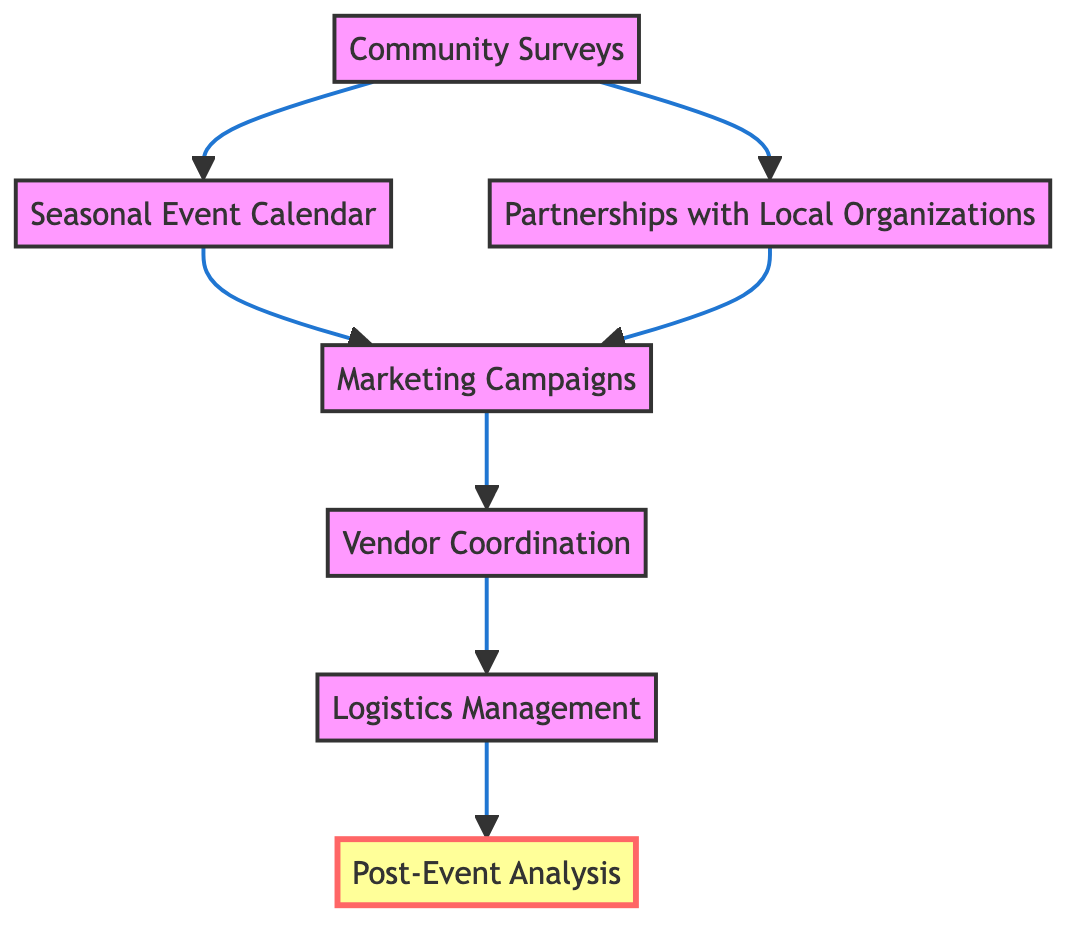What is the first step in the flow chart? The diagram indicates that "Community Surveys" is the first step, as it is the starting point and connects to further actions.
Answer: Community Surveys How many nodes are in the diagram? The diagram shows a total of 7 distinct nodes: Community Surveys, Seasonal Event Calendar, Partnerships with Local Organizations, Marketing Campaigns, Vendor Coordination, Logistics Management, and Post-Event Analysis.
Answer: 7 What connects "Community Surveys" to "Marketing Campaigns"? "Community Surveys" connects to "Marketing Campaigns" through two paths: one leading through "Seasonal Event Calendar" and the other through "Partnerships with Local Organizations."
Answer: Two paths Which node is associated with evaluating events? The last node, "Post-Event Analysis," focuses on evaluating attendance and feedback to enhance future events, thus is associated with evaluation.
Answer: Post-Event Analysis What is the last action in the flow? The last action in the flow is "Post-Event Analysis," which comes after all planning and execution steps have been completed.
Answer: Post-Event Analysis How many connections lead to "Vendor Coordination"? There are two connections leading to "Vendor Coordination": one from "Marketing Campaigns" and one from "Partnerships with Local Organizations."
Answer: Two connections What is the relationship between "Logistics Management" and "Post-Event Analysis"? "Logistics Management" is a prerequisite for "Post-Event Analysis," as it must occur before evaluating events, indicating a sequential relationship.
Answer: Sequential relationship What type of entities are involved in "Partnerships with Local Organizations"? The node “Partnerships with Local Organizations” involves schools, non-profits, and businesses, indicating collaboration with various local entities.
Answer: Schools, non-profits, businesses What is the main purpose of "Marketing Campaigns"? The main purpose of "Marketing Campaigns" is to attract visitors to the events being held, thus it emphasizes promotion and outreach.
Answer: Attract visitors 